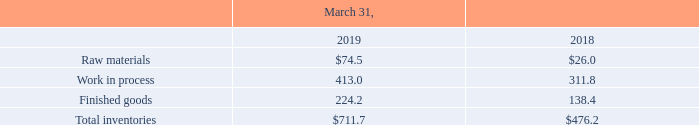Inventories
The components of inventories consist of the following (in millions):
Inventories are valued at the lower of cost and net realizable value using the first-in, first-out method. Inventory impairment charges establish a new cost basis for inventory and charges are not subsequently reversed to income even if circumstances later suggest that increased carrying amounts are recoverable.
How were inventories valued at the lower of cost and net realizable value? Using the first-in, first-out method. Which years does the table provide information for the components of inventories? 2019, 2018. What was the amount of raw materials in 2018?
Answer scale should be: million. 26.0. What was the change in raw materials between 2018 and 2019?
Answer scale should be: million. 74.5-26.0
Answer: 48.5. How many years did the amount of Finished goods exceed $200 million? 2019
Answer: 1. What was the percentage change in total inventories between 2018 and 2019?
Answer scale should be: percent. (711.7-476.2)/476.2
Answer: 49.45. 